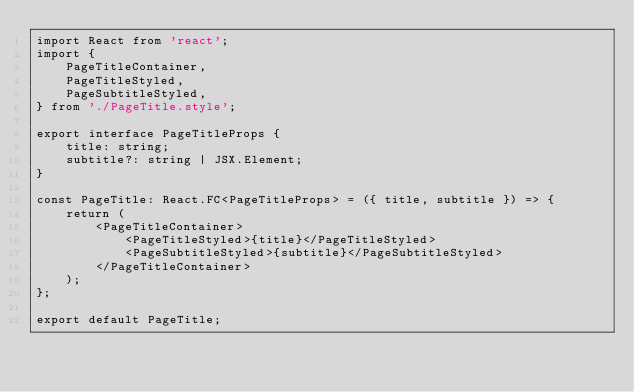<code> <loc_0><loc_0><loc_500><loc_500><_TypeScript_>import React from 'react';
import {
    PageTitleContainer,
    PageTitleStyled,
    PageSubtitleStyled,
} from './PageTitle.style';

export interface PageTitleProps {
    title: string;
    subtitle?: string | JSX.Element;
}

const PageTitle: React.FC<PageTitleProps> = ({ title, subtitle }) => {
    return (
        <PageTitleContainer>
            <PageTitleStyled>{title}</PageTitleStyled>
            <PageSubtitleStyled>{subtitle}</PageSubtitleStyled>
        </PageTitleContainer>
    );
};

export default PageTitle;
</code> 